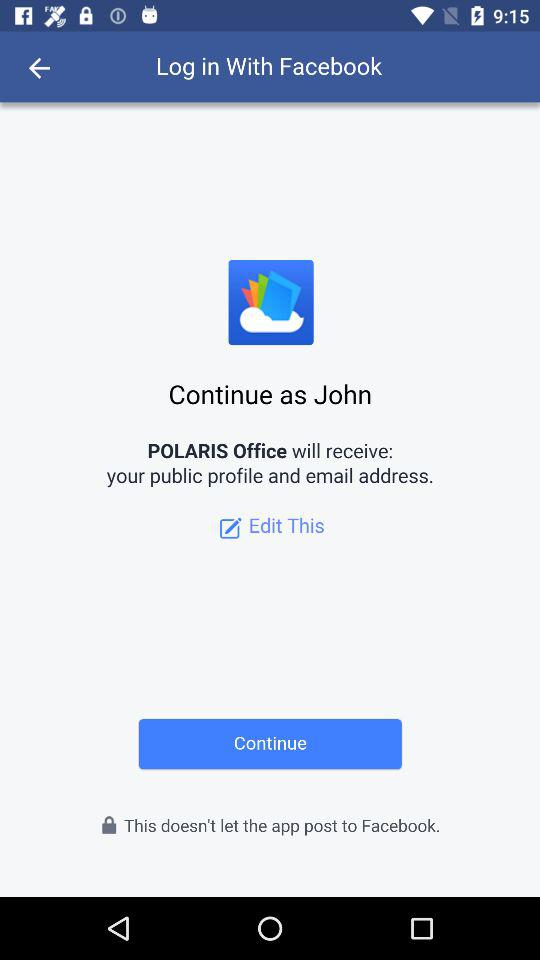Through what application is the person logging in? The person is logging in through "Facebook". 